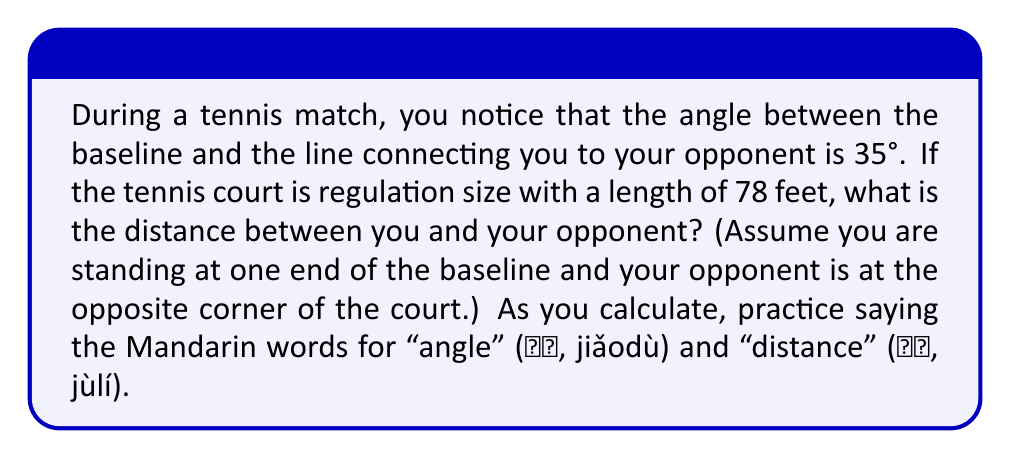Could you help me with this problem? Let's approach this step-by-step:

1) First, let's visualize the problem:

[asy]
unitsize(2mm);
pair A=(0,0), B=(78,0), C=(78,36);
draw(A--B--C--A);
draw(A--C,dashed);
label("You", A, SW);
label("Opponent", C, NE);
label("78 feet", (39,0), S);
label("35°", (5,3));
label("x", (39,18), NW);
[/asy]

2) We have a right triangle. We know:
   - The adjacent side (length of the court) is 78 feet
   - The angle between the baseline and the line to the opponent is 35°
   - We need to find the hypotenuse (距离, jùlí)

3) This is a perfect scenario to use the cosine function. Recall:

   $$ \cos(\theta) = \frac{\text{adjacent}}{\text{hypotenuse}} $$

4) Let's call the distance we're looking for $x$. We can write:

   $$ \cos(35°) = \frac{78}{x} $$

5) To solve for $x$, we multiply both sides by $x$:

   $$ x \cdot \cos(35°) = 78 $$

6) Then divide both sides by $\cos(35°)$:

   $$ x = \frac{78}{\cos(35°)} $$

7) Now we can calculate:

   $$ x = \frac{78}{\cos(35°)} \approx 95.27 \text{ feet} $$

Remember, 角度 (jiǎodù) is "angle" in Mandarin, which we used in our calculation!
Answer: The distance between you and your opponent is approximately 95.27 feet. 